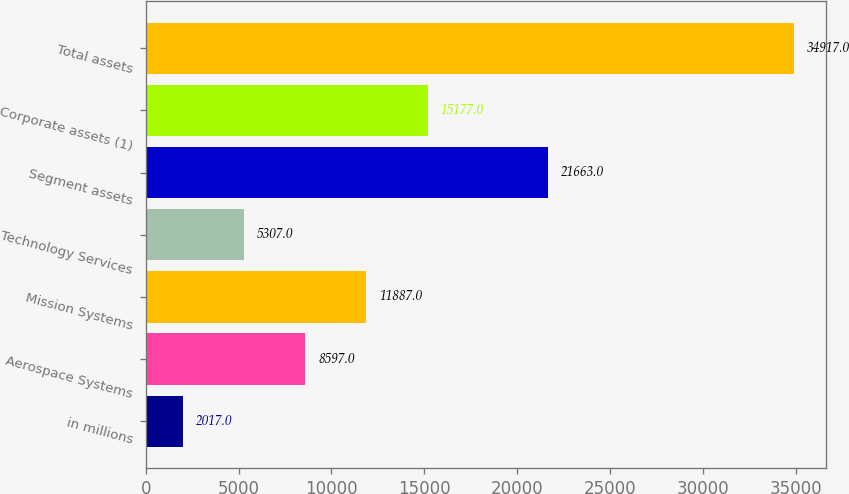Convert chart. <chart><loc_0><loc_0><loc_500><loc_500><bar_chart><fcel>in millions<fcel>Aerospace Systems<fcel>Mission Systems<fcel>Technology Services<fcel>Segment assets<fcel>Corporate assets (1)<fcel>Total assets<nl><fcel>2017<fcel>8597<fcel>11887<fcel>5307<fcel>21663<fcel>15177<fcel>34917<nl></chart> 